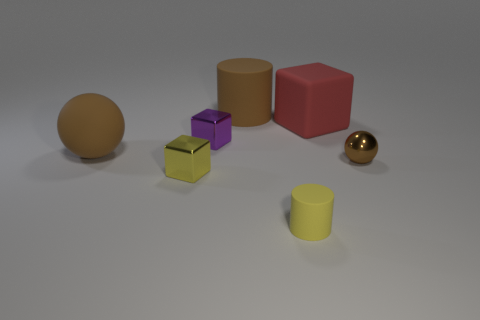Can you describe the colors and shapes visible in the image? Certainly! The image showcases a collection of 3D objects with various colors and shapes. There's a golden sphere and a golden cube, which have a shiny texture. Aside from those, we can see a matte purple cube, a matte orange cylinder, a matte red cube, and a matte yellow cylinder. Each object has its distinct color and shape, contributing to a visually interesting composition. 